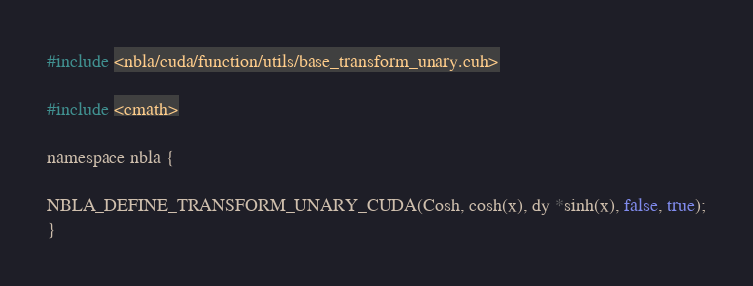Convert code to text. <code><loc_0><loc_0><loc_500><loc_500><_Cuda_>#include <nbla/cuda/function/utils/base_transform_unary.cuh>

#include <cmath>

namespace nbla {

NBLA_DEFINE_TRANSFORM_UNARY_CUDA(Cosh, cosh(x), dy *sinh(x), false, true);
}
</code> 